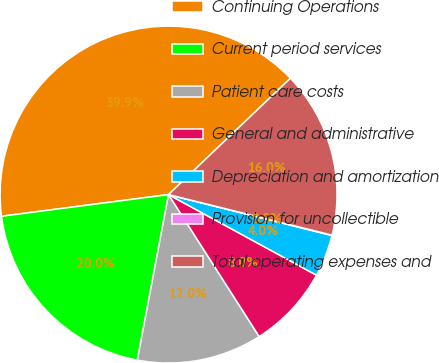Convert chart to OTSL. <chart><loc_0><loc_0><loc_500><loc_500><pie_chart><fcel>Continuing Operations<fcel>Current period services<fcel>Patient care costs<fcel>General and administrative<fcel>Depreciation and amortization<fcel>Provision for uncollectible<fcel>Total operating expenses and<nl><fcel>39.93%<fcel>19.98%<fcel>12.01%<fcel>8.02%<fcel>4.03%<fcel>0.04%<fcel>16.0%<nl></chart> 